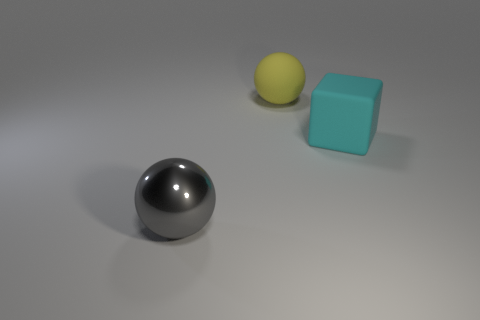There is a big sphere that is behind the big object that is on the left side of the big yellow object; what number of spheres are in front of it?
Offer a very short reply. 1. What is the color of the large object behind the large cyan rubber cube?
Provide a succinct answer. Yellow. There is a matte object that is the same shape as the gray metallic object; what size is it?
Offer a terse response. Large. What is the material of the large thing behind the object that is to the right of the rubber object that is behind the big cube?
Your answer should be very brief. Rubber. Is the number of large gray shiny things on the left side of the cyan matte block greater than the number of big gray metal spheres that are behind the yellow thing?
Make the answer very short. Yes. There is a metallic object that is the same shape as the large yellow matte thing; what color is it?
Offer a very short reply. Gray. How many big cubes have the same color as the matte ball?
Your answer should be very brief. 0. Are there more matte objects that are behind the large shiny ball than small red shiny blocks?
Offer a terse response. Yes. The ball that is in front of the rubber thing that is in front of the yellow thing is what color?
Provide a short and direct response. Gray. How many objects are big objects behind the large gray ball or large objects in front of the large yellow matte sphere?
Keep it short and to the point. 3. 